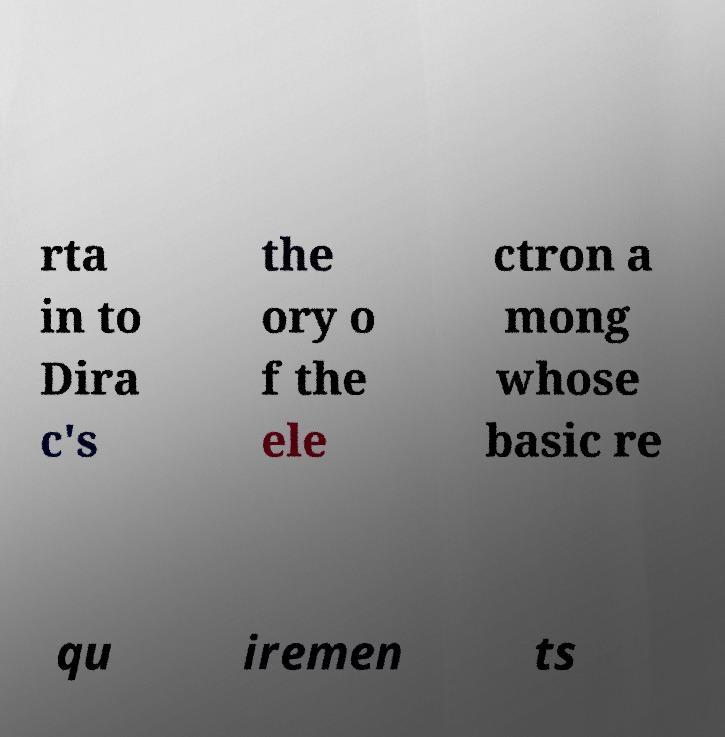Can you read and provide the text displayed in the image?This photo seems to have some interesting text. Can you extract and type it out for me? rta in to Dira c's the ory o f the ele ctron a mong whose basic re qu iremen ts 